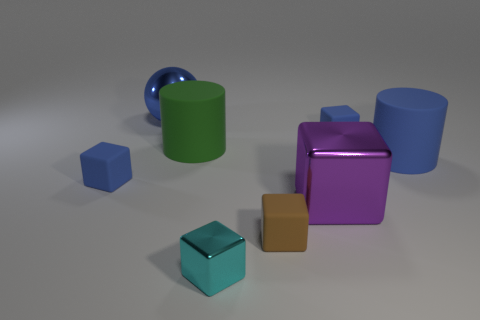There is a big thing that is the same color as the shiny sphere; what shape is it?
Your answer should be compact. Cylinder. Does the rubber block in front of the large purple block have the same size as the metal block in front of the big purple thing?
Make the answer very short. Yes. How many large blocks are the same color as the sphere?
Give a very brief answer. 0. Is the number of small brown matte blocks in front of the large sphere greater than the number of yellow metallic cylinders?
Offer a terse response. Yes. Is the shape of the tiny cyan thing the same as the tiny brown matte thing?
Your answer should be compact. Yes. How many objects are the same material as the big purple cube?
Offer a very short reply. 2. What size is the brown matte thing that is the same shape as the large purple thing?
Offer a terse response. Small. Is the blue cylinder the same size as the brown thing?
Your answer should be compact. No. What shape is the big metallic thing that is in front of the small blue thing in front of the tiny cube behind the green thing?
Make the answer very short. Cube. The other metallic thing that is the same shape as the purple thing is what color?
Give a very brief answer. Cyan. 